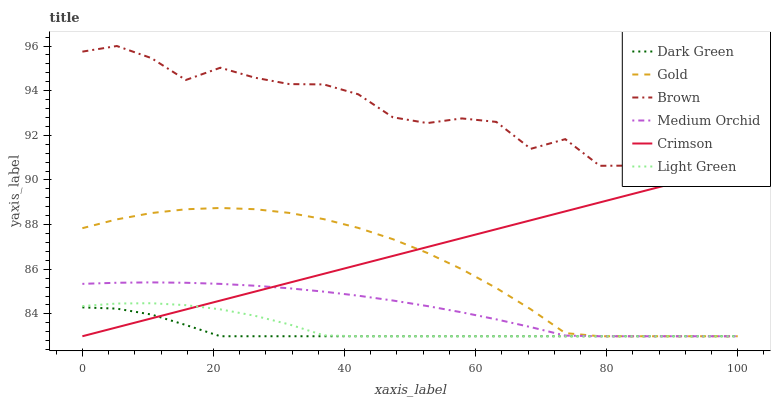Does Dark Green have the minimum area under the curve?
Answer yes or no. Yes. Does Brown have the maximum area under the curve?
Answer yes or no. Yes. Does Gold have the minimum area under the curve?
Answer yes or no. No. Does Gold have the maximum area under the curve?
Answer yes or no. No. Is Crimson the smoothest?
Answer yes or no. Yes. Is Brown the roughest?
Answer yes or no. Yes. Is Gold the smoothest?
Answer yes or no. No. Is Gold the roughest?
Answer yes or no. No. Does Gold have the lowest value?
Answer yes or no. Yes. Does Brown have the highest value?
Answer yes or no. Yes. Does Gold have the highest value?
Answer yes or no. No. Is Light Green less than Brown?
Answer yes or no. Yes. Is Brown greater than Gold?
Answer yes or no. Yes. Does Gold intersect Crimson?
Answer yes or no. Yes. Is Gold less than Crimson?
Answer yes or no. No. Is Gold greater than Crimson?
Answer yes or no. No. Does Light Green intersect Brown?
Answer yes or no. No. 